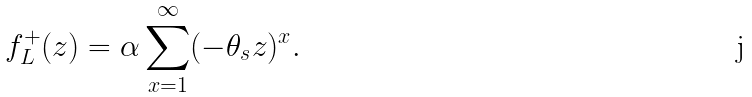<formula> <loc_0><loc_0><loc_500><loc_500>f ^ { + } _ { L } ( z ) = \alpha \sum _ { x = 1 } ^ { \infty } ( - \theta _ { s } z ) ^ { x } .</formula> 